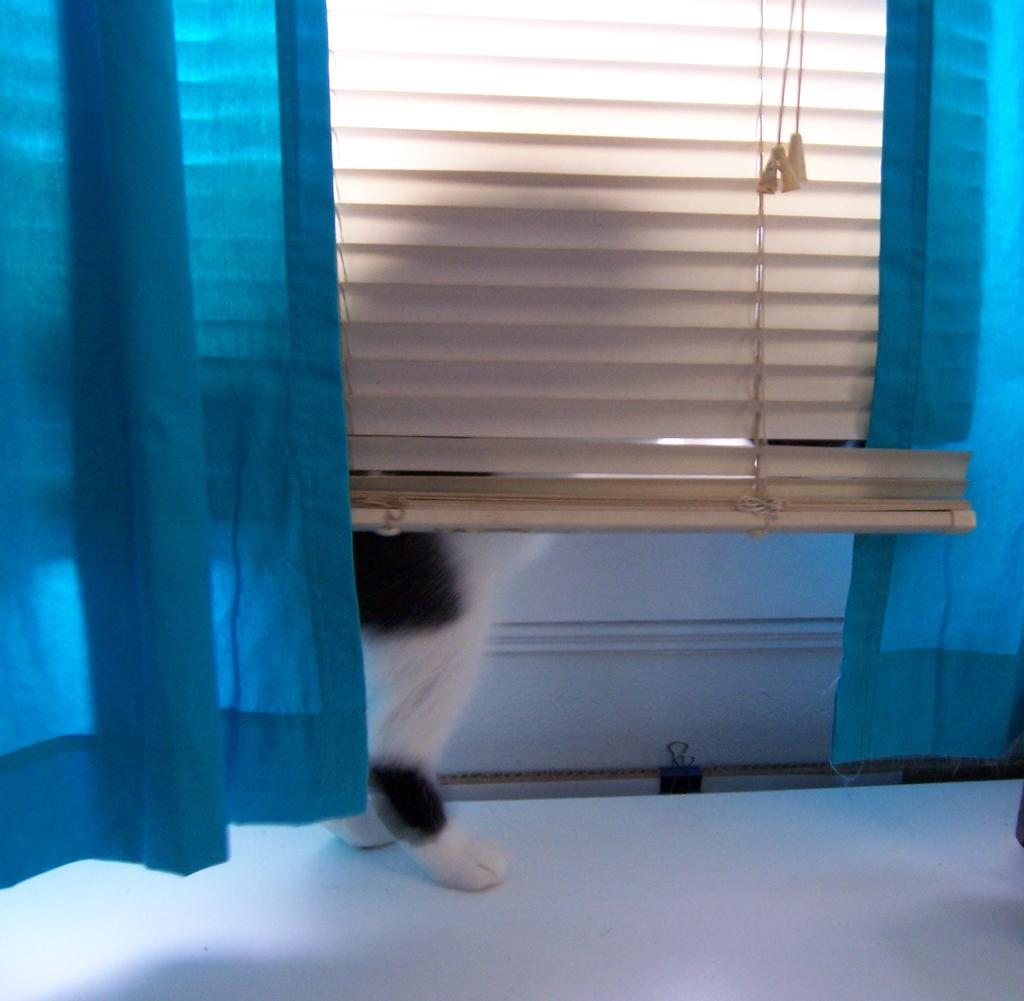What type of body parts are visible in the image? There are animal legs in the image. What type of window treatment can be seen in the image? There are curtains in the image. What type of structure is present in the image? There is a wall in the image. What type of string is visible in the image? There is no string present in the image. What type of picture is hanging on the wall in the image? There is no picture hanging on the wall in the image. 